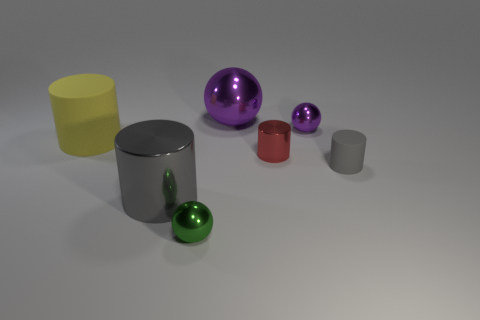What number of objects are behind the small thing in front of the matte thing that is on the right side of the big yellow object?
Your answer should be compact. 6. The sphere that is both right of the small green sphere and in front of the large purple shiny ball is made of what material?
Offer a very short reply. Metal. Does the red thing have the same material as the gray object that is right of the green sphere?
Provide a short and direct response. No. Is the number of small metal cylinders in front of the gray rubber thing greater than the number of big purple objects on the right side of the red object?
Your answer should be very brief. No. There is a small gray thing; what shape is it?
Offer a very short reply. Cylinder. Does the tiny cylinder that is to the right of the tiny purple metallic sphere have the same material as the ball that is in front of the large yellow thing?
Keep it short and to the point. No. What shape is the small thing behind the yellow object?
Your answer should be very brief. Sphere. The red thing that is the same shape as the gray shiny thing is what size?
Give a very brief answer. Small. Is the small shiny cylinder the same color as the large rubber cylinder?
Your response must be concise. No. Is there any other thing that has the same shape as the tiny matte thing?
Your answer should be compact. Yes. 